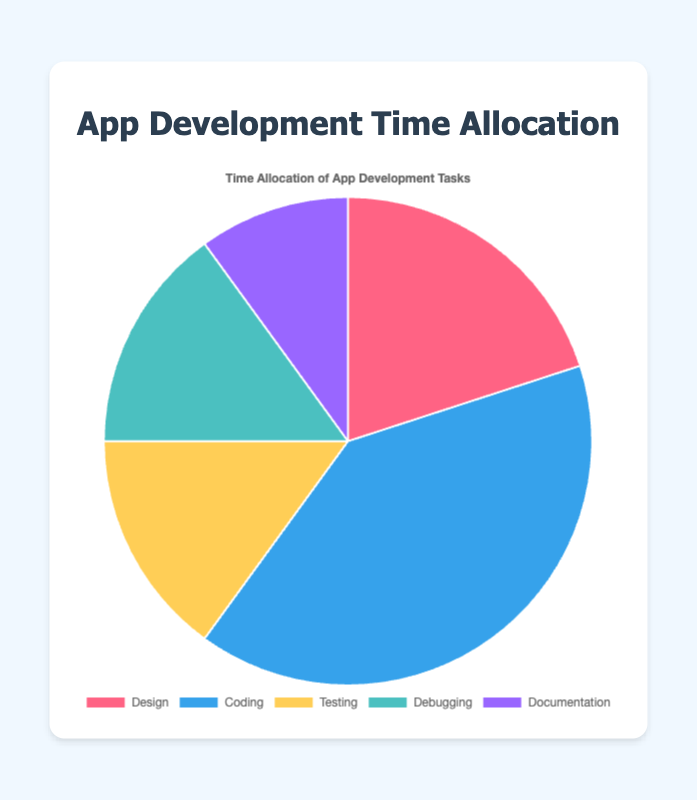What percentage of the time is allocated to Coding tasks? Locate the "Coding" section of the pie chart. The figure shows that Coding accounts for 40% of the time allocation.
Answer: 40% What is the combined percentage of time allocated to Testing and Debugging? Locate the "Testing" and "Debugging" sections of the pie chart. Testing accounts for 15% and Debugging accounts for 15%. Adding them together: 15% + 15% = 30%.
Answer: 30% Which task has the smallest percentage of time allocation? Look at all sections of the pie chart and identify the one with the smallest percentage. The "Documentation" section is the smallest with 10%.
Answer: Documentation Which task takes twice as much time as Design? Look at the percentage for Design, which is 20%. Find a task that is twice that amount: 2 * 20% = 40%. The task with 40% is "Coding".
Answer: Coding What is the total percentage of time allocated to the tasks except for Coding? Calculate the total percentage of time for all tasks except Coding. Add the percentages for Design (20%), Testing (15%), Debugging (15%), and Documentation (10%): 20% + 15% + 15% + 10% = 60%.
Answer: 60% Which sections of the pie chart are visually the same size? Look at the chart and identify sections that appear to be the same size. "Testing" and "Debugging" both account for 15%, making them visually the same size.
Answer: Testing and Debugging Is the percentage of time allocated to Documentation greater than, less than, or equal to the time allocated to Debugging? Compare the percentages of Documentation (10%) and Debugging (15%) directly. 10% is less than 15%.
Answer: Less than What is the total time allocation for the three tasks with the highest percentages? Identify the tasks with the highest percentages, which are Coding (40%), Design (20%), and Testing (15%). Sum these percentages: 40% + 20% + 15% = 75%.
Answer: 75% 